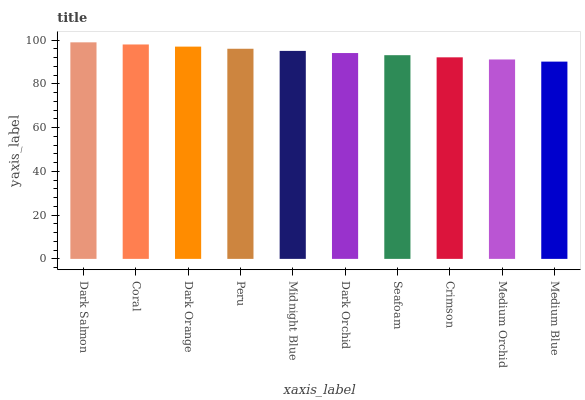Is Coral the minimum?
Answer yes or no. No. Is Coral the maximum?
Answer yes or no. No. Is Dark Salmon greater than Coral?
Answer yes or no. Yes. Is Coral less than Dark Salmon?
Answer yes or no. Yes. Is Coral greater than Dark Salmon?
Answer yes or no. No. Is Dark Salmon less than Coral?
Answer yes or no. No. Is Midnight Blue the high median?
Answer yes or no. Yes. Is Dark Orchid the low median?
Answer yes or no. Yes. Is Dark Salmon the high median?
Answer yes or no. No. Is Medium Orchid the low median?
Answer yes or no. No. 